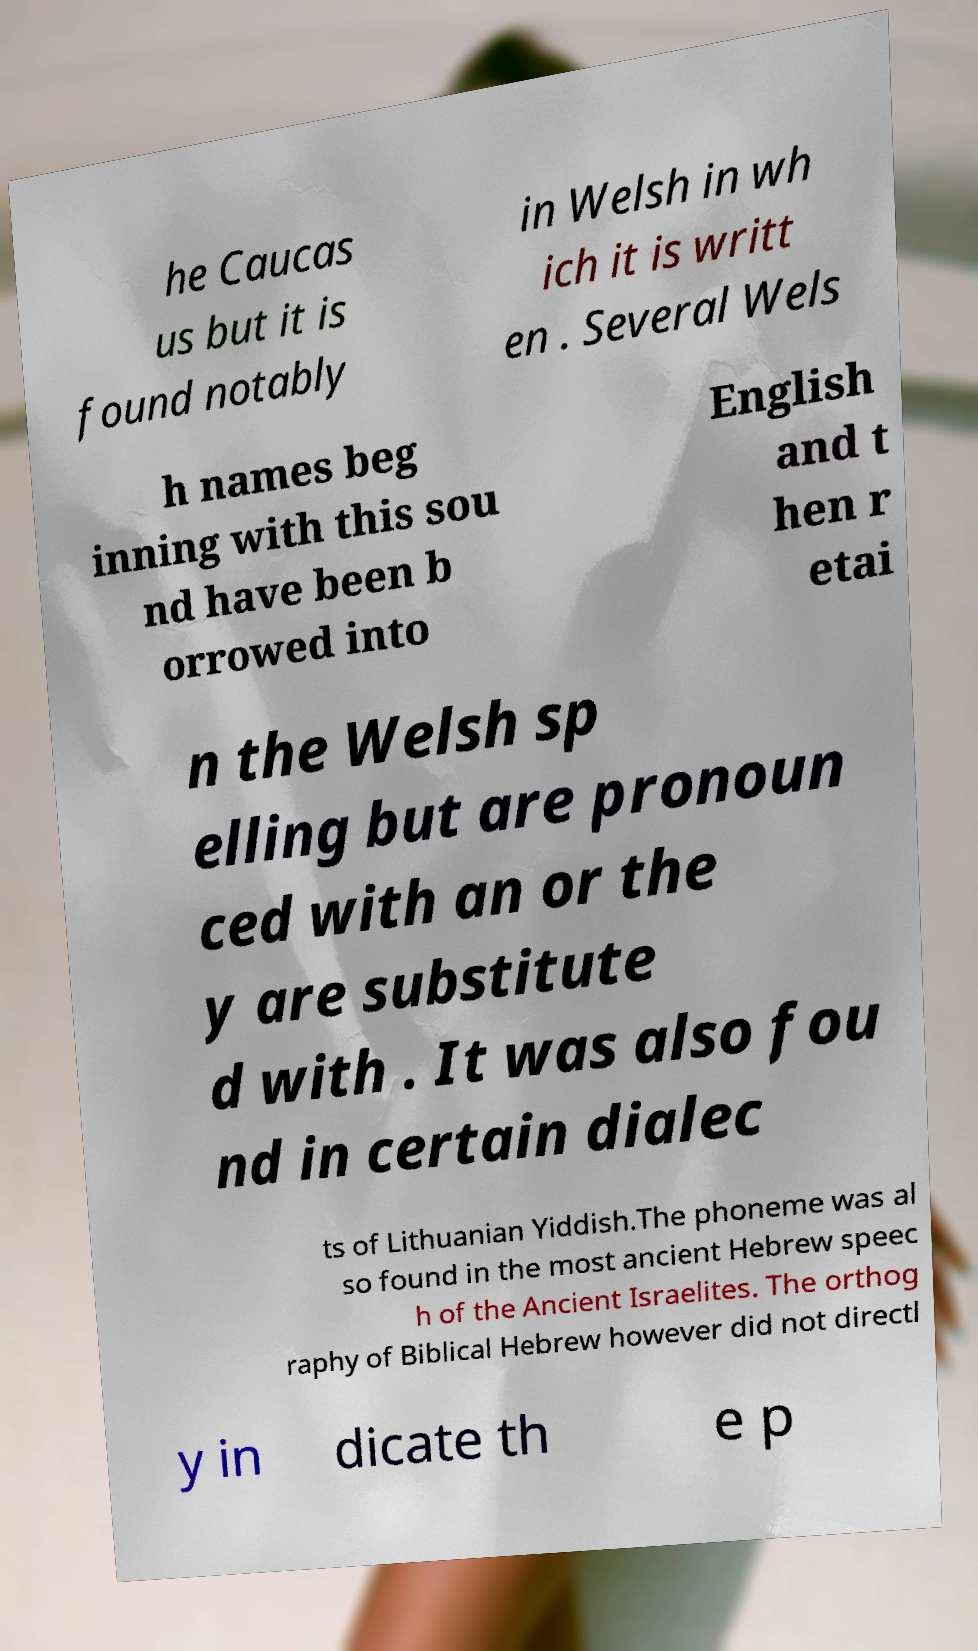Could you assist in decoding the text presented in this image and type it out clearly? he Caucas us but it is found notably in Welsh in wh ich it is writt en . Several Wels h names beg inning with this sou nd have been b orrowed into English and t hen r etai n the Welsh sp elling but are pronoun ced with an or the y are substitute d with . It was also fou nd in certain dialec ts of Lithuanian Yiddish.The phoneme was al so found in the most ancient Hebrew speec h of the Ancient Israelites. The orthog raphy of Biblical Hebrew however did not directl y in dicate th e p 